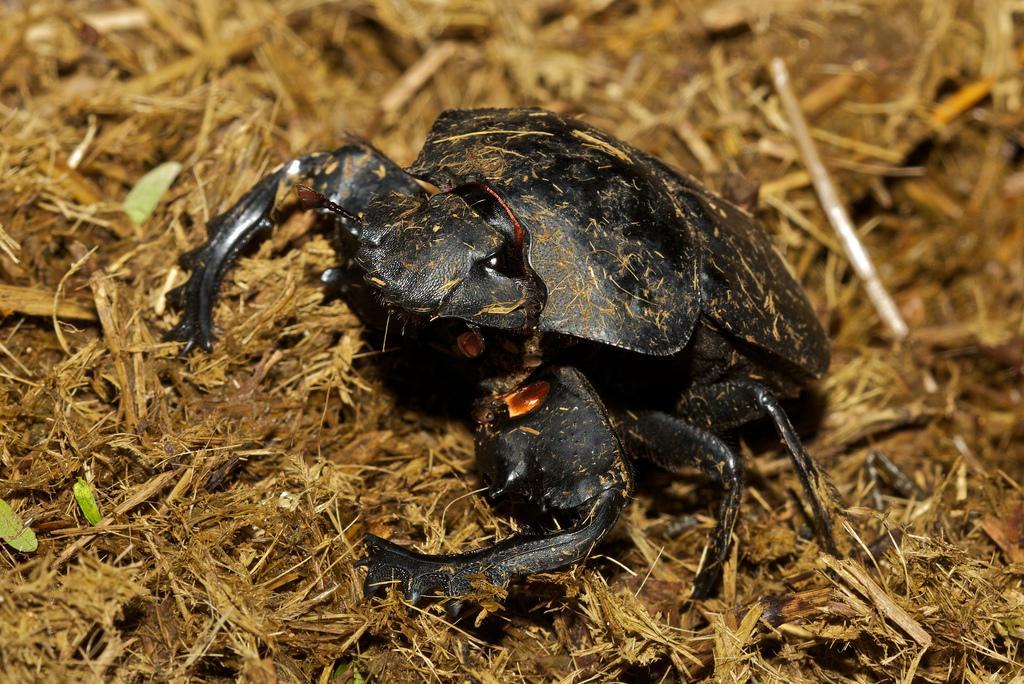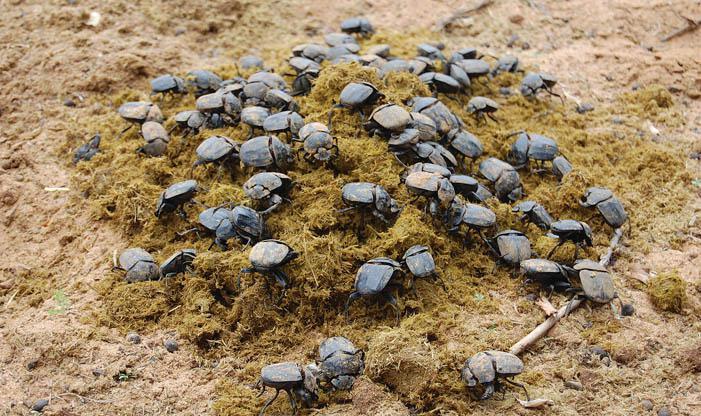The first image is the image on the left, the second image is the image on the right. For the images displayed, is the sentence "An image shows one beetle in contact with one round dung ball." factually correct? Answer yes or no. No. The first image is the image on the left, the second image is the image on the right. Assess this claim about the two images: "Two beetles crawl across the ground.". Correct or not? Answer yes or no. No. 